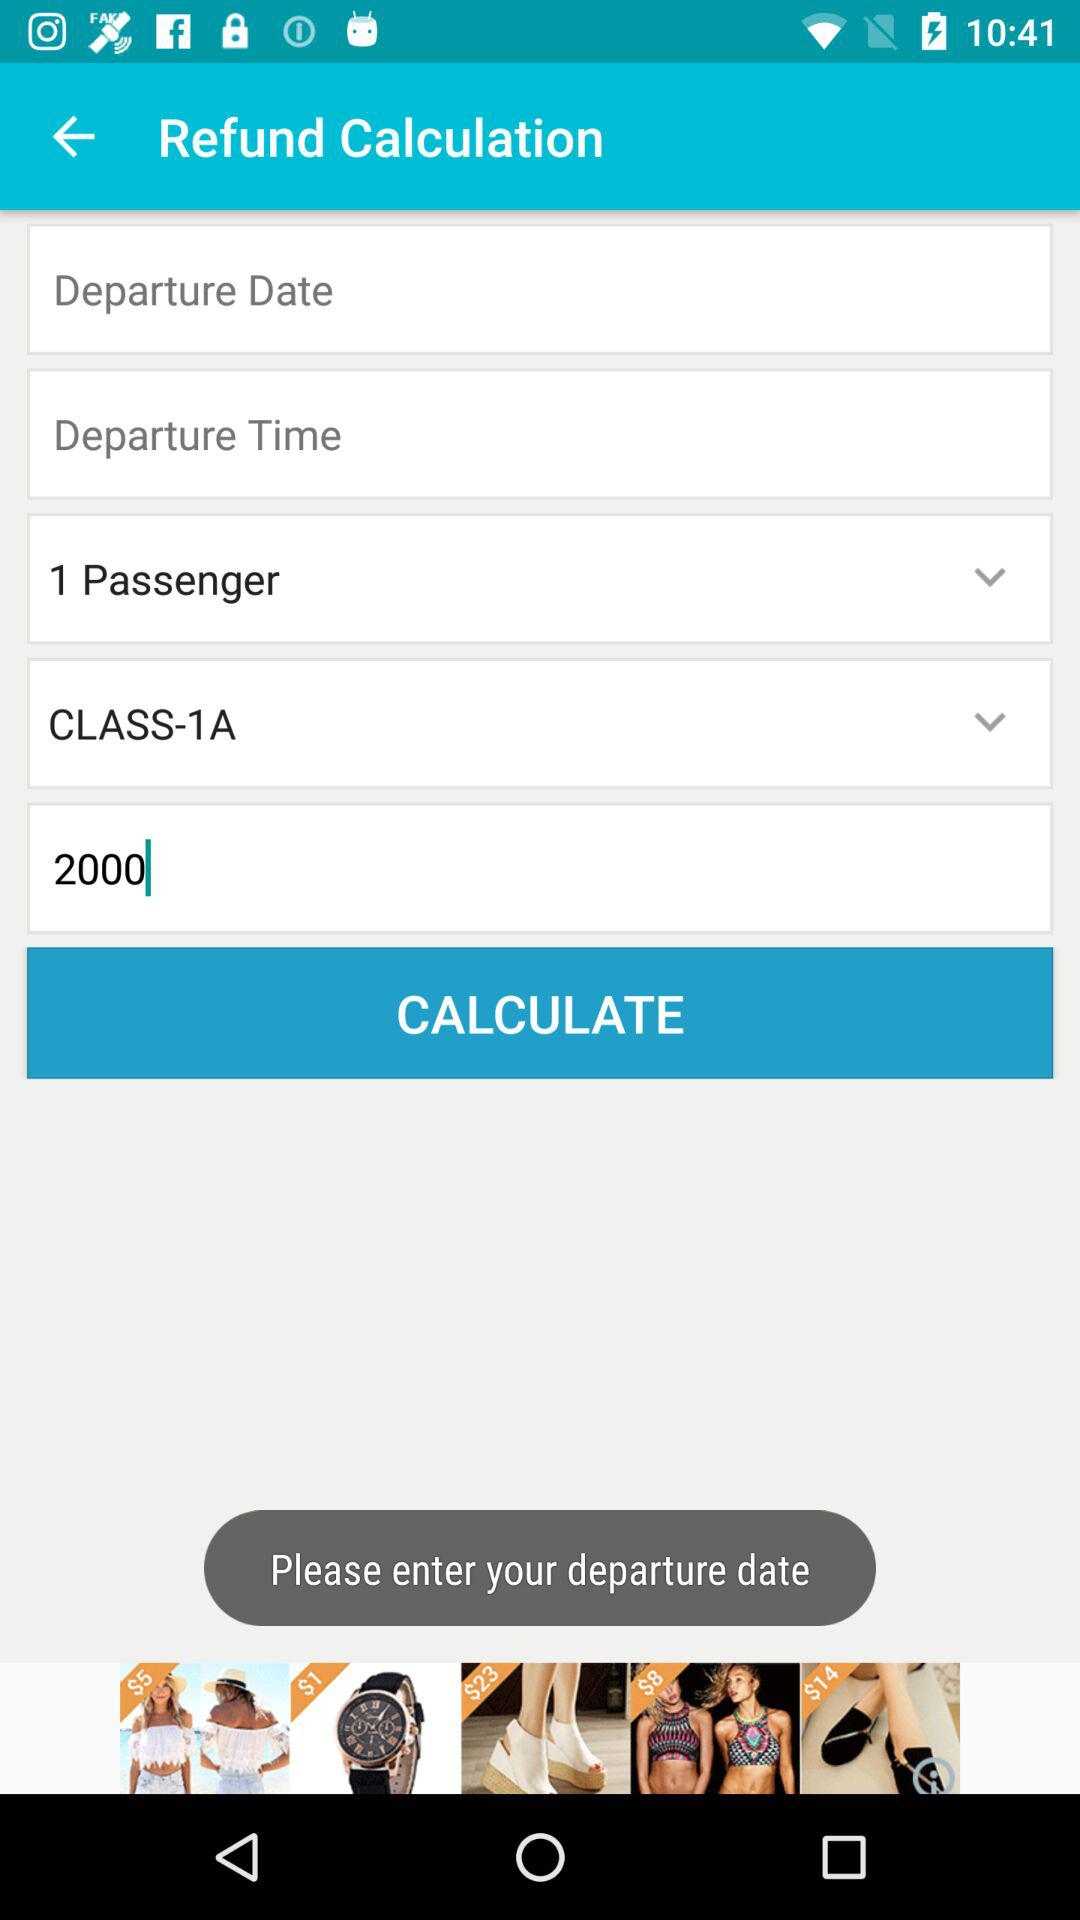What is the amount of the refund? The amount of the refund is 2000. 